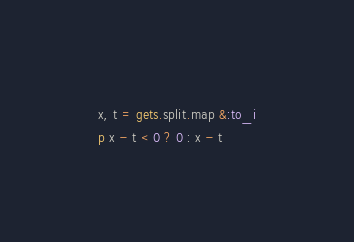<code> <loc_0><loc_0><loc_500><loc_500><_Ruby_>x, t = gets.split.map &:to_i
p x - t < 0 ? 0 : x - t</code> 